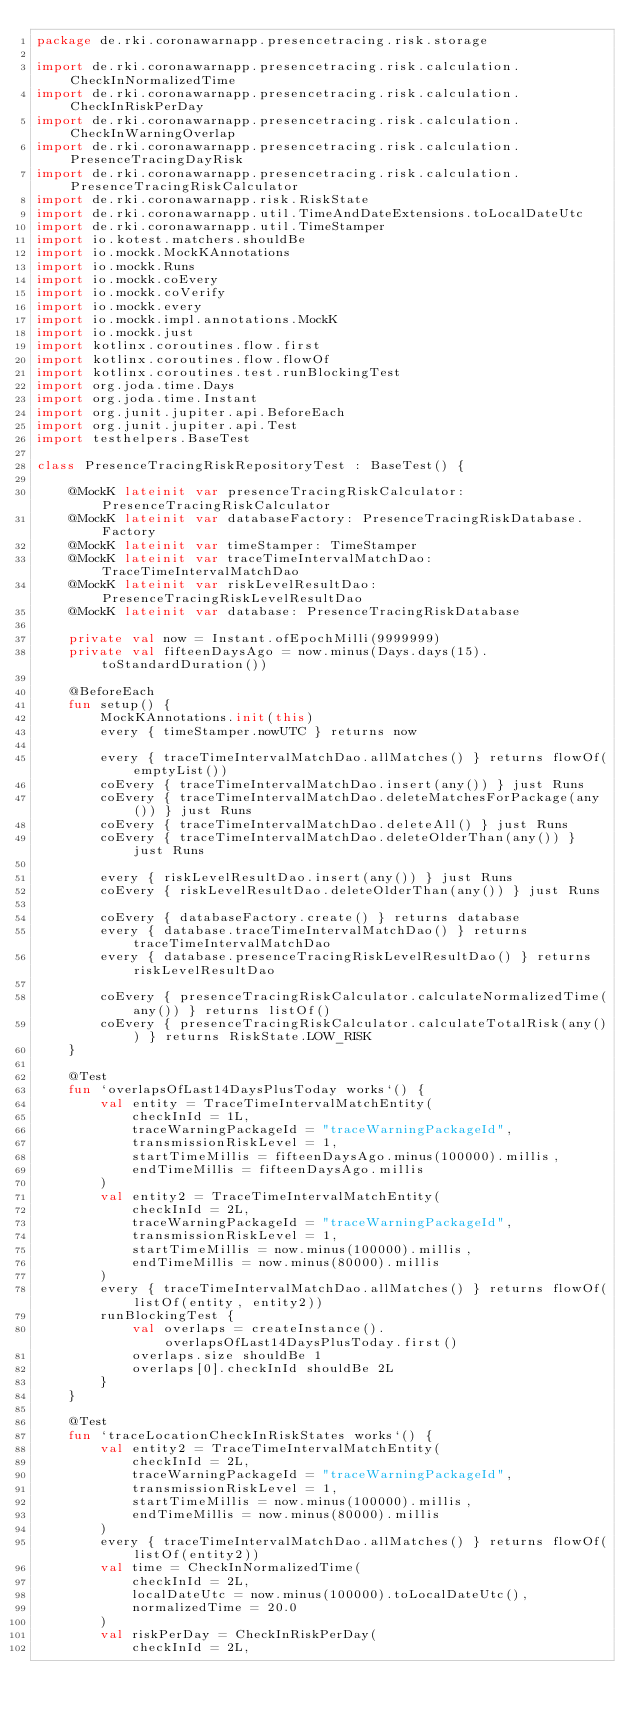Convert code to text. <code><loc_0><loc_0><loc_500><loc_500><_Kotlin_>package de.rki.coronawarnapp.presencetracing.risk.storage

import de.rki.coronawarnapp.presencetracing.risk.calculation.CheckInNormalizedTime
import de.rki.coronawarnapp.presencetracing.risk.calculation.CheckInRiskPerDay
import de.rki.coronawarnapp.presencetracing.risk.calculation.CheckInWarningOverlap
import de.rki.coronawarnapp.presencetracing.risk.calculation.PresenceTracingDayRisk
import de.rki.coronawarnapp.presencetracing.risk.calculation.PresenceTracingRiskCalculator
import de.rki.coronawarnapp.risk.RiskState
import de.rki.coronawarnapp.util.TimeAndDateExtensions.toLocalDateUtc
import de.rki.coronawarnapp.util.TimeStamper
import io.kotest.matchers.shouldBe
import io.mockk.MockKAnnotations
import io.mockk.Runs
import io.mockk.coEvery
import io.mockk.coVerify
import io.mockk.every
import io.mockk.impl.annotations.MockK
import io.mockk.just
import kotlinx.coroutines.flow.first
import kotlinx.coroutines.flow.flowOf
import kotlinx.coroutines.test.runBlockingTest
import org.joda.time.Days
import org.joda.time.Instant
import org.junit.jupiter.api.BeforeEach
import org.junit.jupiter.api.Test
import testhelpers.BaseTest

class PresenceTracingRiskRepositoryTest : BaseTest() {

    @MockK lateinit var presenceTracingRiskCalculator: PresenceTracingRiskCalculator
    @MockK lateinit var databaseFactory: PresenceTracingRiskDatabase.Factory
    @MockK lateinit var timeStamper: TimeStamper
    @MockK lateinit var traceTimeIntervalMatchDao: TraceTimeIntervalMatchDao
    @MockK lateinit var riskLevelResultDao: PresenceTracingRiskLevelResultDao
    @MockK lateinit var database: PresenceTracingRiskDatabase

    private val now = Instant.ofEpochMilli(9999999)
    private val fifteenDaysAgo = now.minus(Days.days(15).toStandardDuration())

    @BeforeEach
    fun setup() {
        MockKAnnotations.init(this)
        every { timeStamper.nowUTC } returns now

        every { traceTimeIntervalMatchDao.allMatches() } returns flowOf(emptyList())
        coEvery { traceTimeIntervalMatchDao.insert(any()) } just Runs
        coEvery { traceTimeIntervalMatchDao.deleteMatchesForPackage(any()) } just Runs
        coEvery { traceTimeIntervalMatchDao.deleteAll() } just Runs
        coEvery { traceTimeIntervalMatchDao.deleteOlderThan(any()) } just Runs

        every { riskLevelResultDao.insert(any()) } just Runs
        coEvery { riskLevelResultDao.deleteOlderThan(any()) } just Runs

        coEvery { databaseFactory.create() } returns database
        every { database.traceTimeIntervalMatchDao() } returns traceTimeIntervalMatchDao
        every { database.presenceTracingRiskLevelResultDao() } returns riskLevelResultDao

        coEvery { presenceTracingRiskCalculator.calculateNormalizedTime(any()) } returns listOf()
        coEvery { presenceTracingRiskCalculator.calculateTotalRisk(any()) } returns RiskState.LOW_RISK
    }

    @Test
    fun `overlapsOfLast14DaysPlusToday works`() {
        val entity = TraceTimeIntervalMatchEntity(
            checkInId = 1L,
            traceWarningPackageId = "traceWarningPackageId",
            transmissionRiskLevel = 1,
            startTimeMillis = fifteenDaysAgo.minus(100000).millis,
            endTimeMillis = fifteenDaysAgo.millis
        )
        val entity2 = TraceTimeIntervalMatchEntity(
            checkInId = 2L,
            traceWarningPackageId = "traceWarningPackageId",
            transmissionRiskLevel = 1,
            startTimeMillis = now.minus(100000).millis,
            endTimeMillis = now.minus(80000).millis
        )
        every { traceTimeIntervalMatchDao.allMatches() } returns flowOf(listOf(entity, entity2))
        runBlockingTest {
            val overlaps = createInstance().overlapsOfLast14DaysPlusToday.first()
            overlaps.size shouldBe 1
            overlaps[0].checkInId shouldBe 2L
        }
    }

    @Test
    fun `traceLocationCheckInRiskStates works`() {
        val entity2 = TraceTimeIntervalMatchEntity(
            checkInId = 2L,
            traceWarningPackageId = "traceWarningPackageId",
            transmissionRiskLevel = 1,
            startTimeMillis = now.minus(100000).millis,
            endTimeMillis = now.minus(80000).millis
        )
        every { traceTimeIntervalMatchDao.allMatches() } returns flowOf(listOf(entity2))
        val time = CheckInNormalizedTime(
            checkInId = 2L,
            localDateUtc = now.minus(100000).toLocalDateUtc(),
            normalizedTime = 20.0
        )
        val riskPerDay = CheckInRiskPerDay(
            checkInId = 2L,</code> 